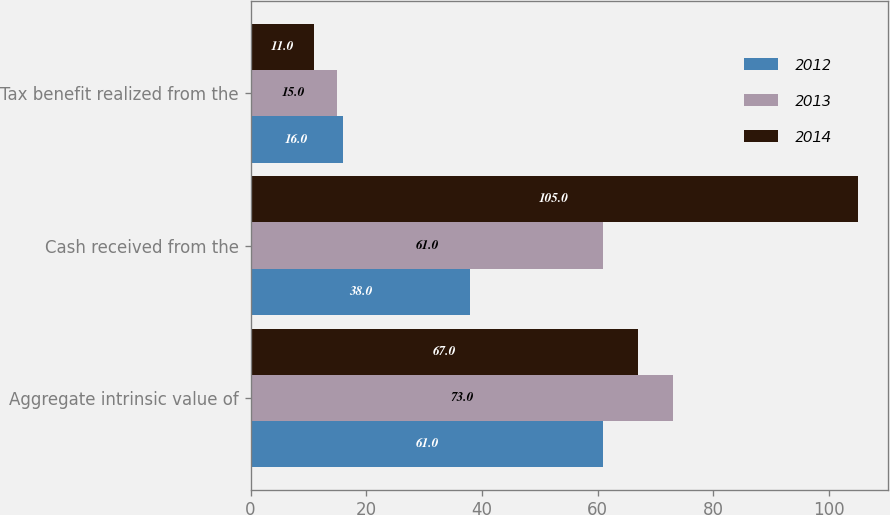Convert chart. <chart><loc_0><loc_0><loc_500><loc_500><stacked_bar_chart><ecel><fcel>Aggregate intrinsic value of<fcel>Cash received from the<fcel>Tax benefit realized from the<nl><fcel>2012<fcel>61<fcel>38<fcel>16<nl><fcel>2013<fcel>73<fcel>61<fcel>15<nl><fcel>2014<fcel>67<fcel>105<fcel>11<nl></chart> 